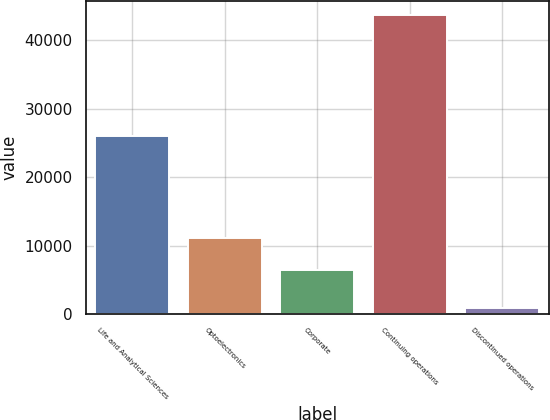Convert chart to OTSL. <chart><loc_0><loc_0><loc_500><loc_500><bar_chart><fcel>Life and Analytical Sciences<fcel>Optoelectronics<fcel>Corporate<fcel>Continuing operations<fcel>Discontinued operations<nl><fcel>25973<fcel>11122<fcel>6497<fcel>43592<fcel>881<nl></chart> 